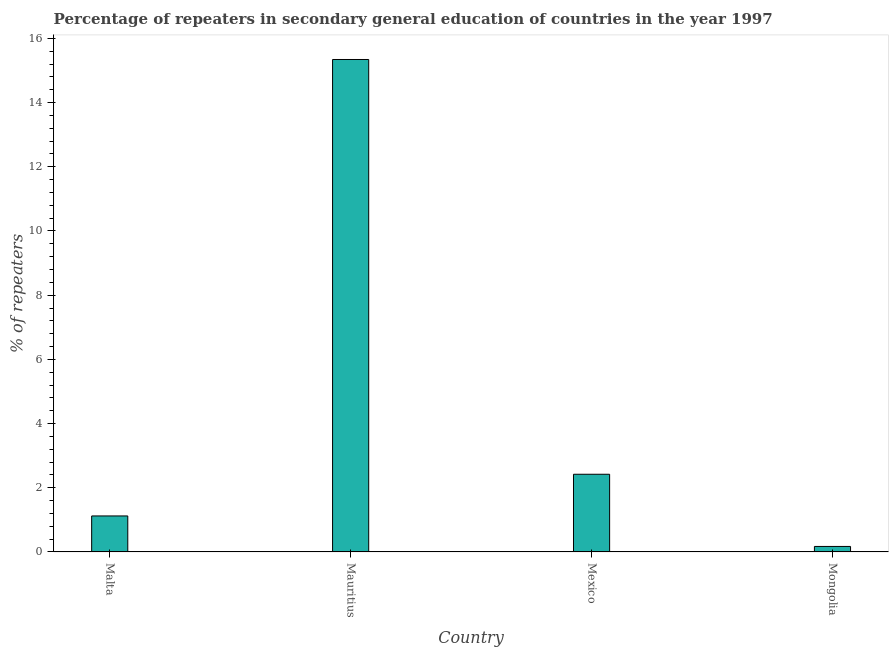What is the title of the graph?
Provide a short and direct response. Percentage of repeaters in secondary general education of countries in the year 1997. What is the label or title of the Y-axis?
Your response must be concise. % of repeaters. What is the percentage of repeaters in Malta?
Give a very brief answer. 1.12. Across all countries, what is the maximum percentage of repeaters?
Provide a short and direct response. 15.34. Across all countries, what is the minimum percentage of repeaters?
Your response must be concise. 0.17. In which country was the percentage of repeaters maximum?
Your answer should be very brief. Mauritius. In which country was the percentage of repeaters minimum?
Give a very brief answer. Mongolia. What is the sum of the percentage of repeaters?
Offer a very short reply. 19.06. What is the difference between the percentage of repeaters in Malta and Mauritius?
Your answer should be very brief. -14.22. What is the average percentage of repeaters per country?
Ensure brevity in your answer.  4.76. What is the median percentage of repeaters?
Make the answer very short. 1.77. In how many countries, is the percentage of repeaters greater than 7.6 %?
Ensure brevity in your answer.  1. What is the ratio of the percentage of repeaters in Malta to that in Mauritius?
Your response must be concise. 0.07. What is the difference between the highest and the second highest percentage of repeaters?
Offer a terse response. 12.92. Is the sum of the percentage of repeaters in Malta and Mauritius greater than the maximum percentage of repeaters across all countries?
Provide a short and direct response. Yes. What is the difference between the highest and the lowest percentage of repeaters?
Provide a succinct answer. 15.17. How many countries are there in the graph?
Give a very brief answer. 4. What is the difference between two consecutive major ticks on the Y-axis?
Make the answer very short. 2. Are the values on the major ticks of Y-axis written in scientific E-notation?
Offer a terse response. No. What is the % of repeaters of Malta?
Ensure brevity in your answer.  1.12. What is the % of repeaters in Mauritius?
Make the answer very short. 15.34. What is the % of repeaters in Mexico?
Make the answer very short. 2.42. What is the % of repeaters of Mongolia?
Ensure brevity in your answer.  0.17. What is the difference between the % of repeaters in Malta and Mauritius?
Offer a terse response. -14.22. What is the difference between the % of repeaters in Malta and Mexico?
Make the answer very short. -1.3. What is the difference between the % of repeaters in Malta and Mongolia?
Provide a short and direct response. 0.95. What is the difference between the % of repeaters in Mauritius and Mexico?
Provide a succinct answer. 12.92. What is the difference between the % of repeaters in Mauritius and Mongolia?
Give a very brief answer. 15.17. What is the difference between the % of repeaters in Mexico and Mongolia?
Give a very brief answer. 2.25. What is the ratio of the % of repeaters in Malta to that in Mauritius?
Your answer should be very brief. 0.07. What is the ratio of the % of repeaters in Malta to that in Mexico?
Your answer should be very brief. 0.46. What is the ratio of the % of repeaters in Malta to that in Mongolia?
Your answer should be compact. 6.56. What is the ratio of the % of repeaters in Mauritius to that in Mexico?
Your answer should be compact. 6.34. What is the ratio of the % of repeaters in Mauritius to that in Mongolia?
Your response must be concise. 89.67. What is the ratio of the % of repeaters in Mexico to that in Mongolia?
Offer a very short reply. 14.14. 